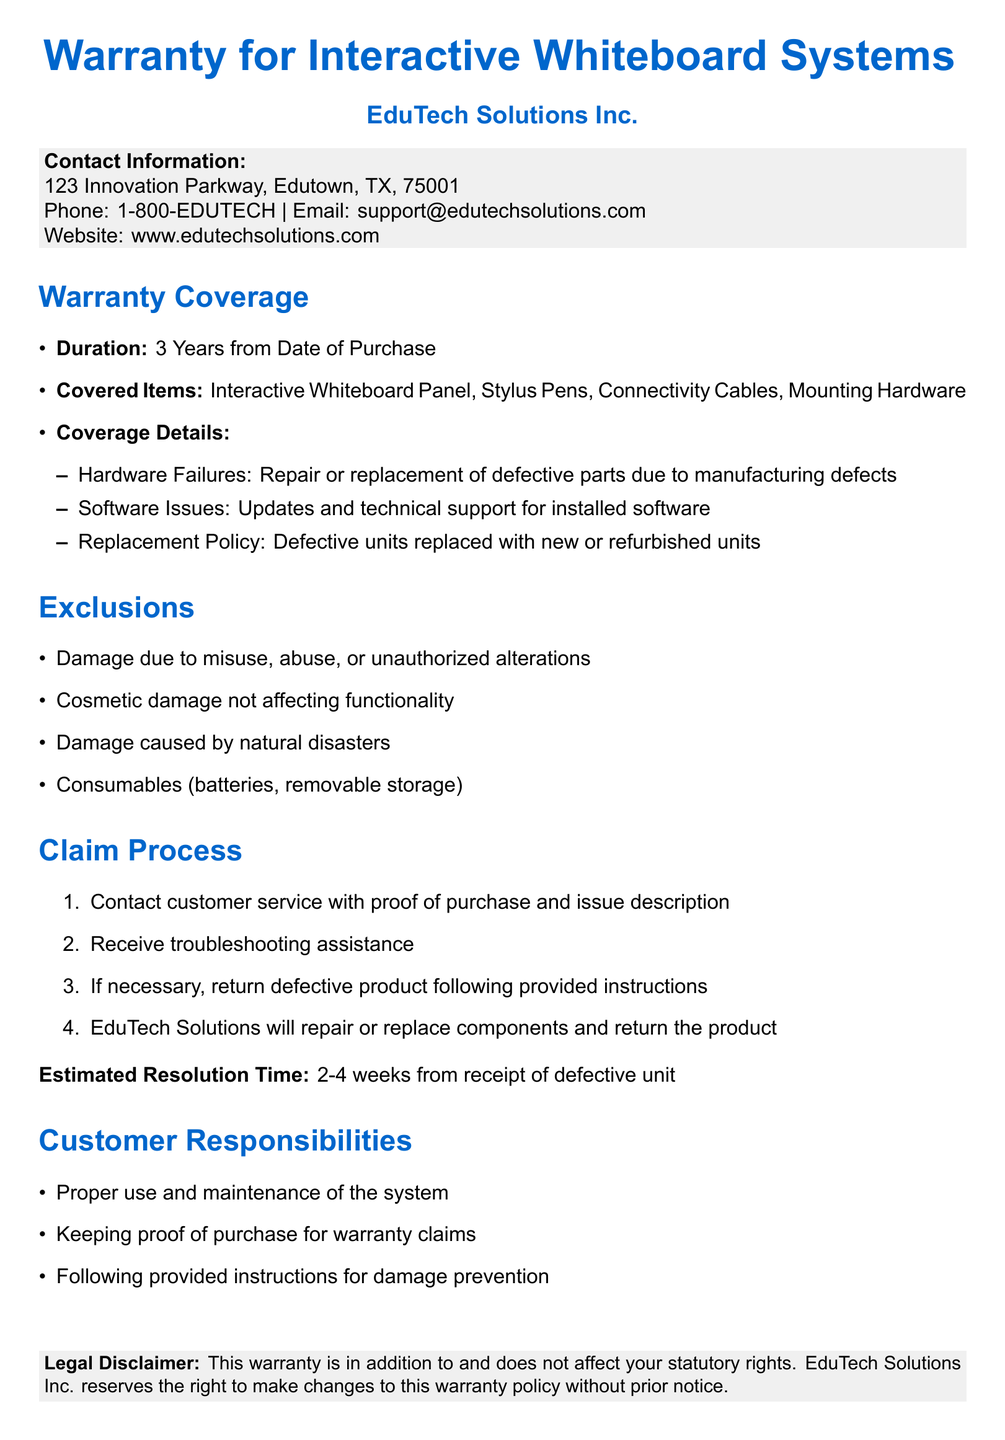What is the duration of the warranty? The warranty duration is specified clearly in the document as 3 years from the date of purchase.
Answer: 3 Years What items are covered under the warranty? The document lists specific items that are covered, including the Interactive Whiteboard Panel and others.
Answer: Interactive Whiteboard Panel, Stylus Pens, Connectivity Cables, Mounting Hardware What type of damage is excluded from the warranty? The document outlines exclusions, including damage due to misuse, abuse, or natural disasters.
Answer: Damage due to misuse, abuse, or natural disasters What must a customer do first to initiate a warranty claim? The document specifies the initial step of contacting customer service with certain information for the warranty claim.
Answer: Contact customer service with proof of purchase and issue description What is the estimated resolution time for warranty claims? An exact time frame for how long customers can expect to wait for a resolution is provided in the document.
Answer: 2-4 weeks What is EduTech Solutions Inc.'s contact email? The document contains the specific email address where customers can reach support for warranty issues.
Answer: support@edutechsolutions.com What is a customer responsibility according to the warranty? The document lists several responsibilities customers have, including proper usage and maintenance of the system.
Answer: Proper use and maintenance of the system 